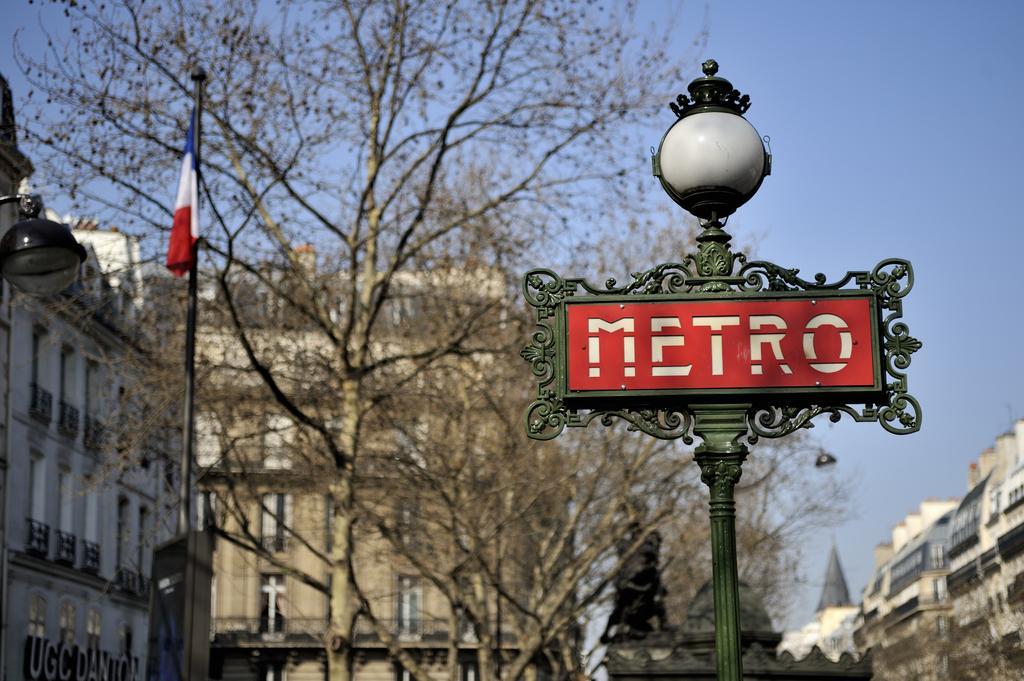How would you summarize this image in a sentence or two? In this image I can see a green colour pole, a red colour board and a light in the front. On this board I can see something is written. In the background I can see few trees, number of buildings and the sky. On the right side of this image I can see a light and a flag. On the bottom left corner side of this image I can see something is written. 